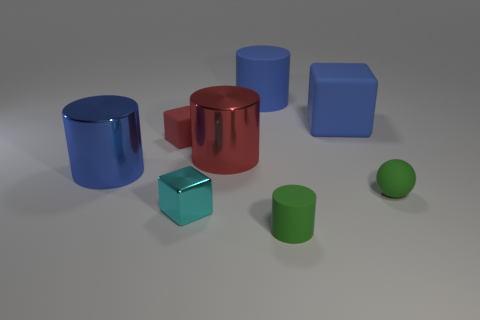Subtract all large matte blocks. How many blocks are left? 2 Add 1 large rubber cylinders. How many objects exist? 9 Subtract all red cylinders. How many cylinders are left? 3 Subtract all spheres. How many objects are left? 7 Subtract 2 cylinders. How many cylinders are left? 2 Subtract 0 gray blocks. How many objects are left? 8 Subtract all red blocks. Subtract all green cylinders. How many blocks are left? 2 Subtract all yellow cylinders. How many blue cubes are left? 1 Subtract all tiny things. Subtract all big green matte cubes. How many objects are left? 4 Add 6 small cyan metal cubes. How many small cyan metal cubes are left? 7 